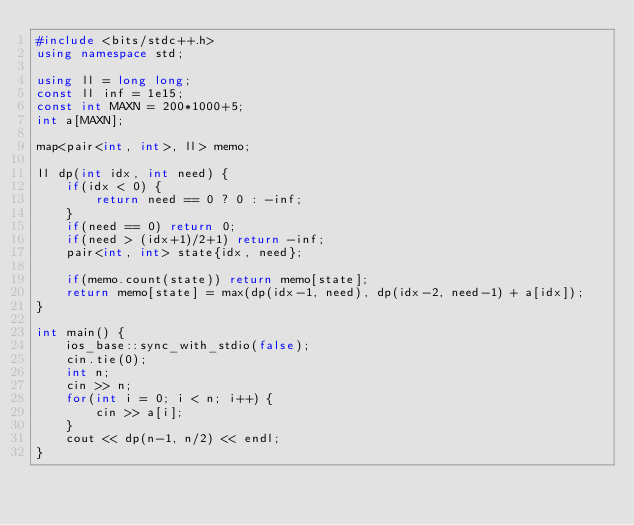<code> <loc_0><loc_0><loc_500><loc_500><_C++_>#include <bits/stdc++.h>
using namespace std;

using ll = long long;
const ll inf = 1e15;
const int MAXN = 200*1000+5;
int a[MAXN];

map<pair<int, int>, ll> memo;

ll dp(int idx, int need) {
    if(idx < 0) {
        return need == 0 ? 0 : -inf;
    }
    if(need == 0) return 0;
    if(need > (idx+1)/2+1) return -inf;
    pair<int, int> state{idx, need};
    
    if(memo.count(state)) return memo[state];
    return memo[state] = max(dp(idx-1, need), dp(idx-2, need-1) + a[idx]);
}

int main() {
    ios_base::sync_with_stdio(false);
    cin.tie(0);
    int n;
    cin >> n;
    for(int i = 0; i < n; i++) {
        cin >> a[i];
    }
    cout << dp(n-1, n/2) << endl;
}
</code> 